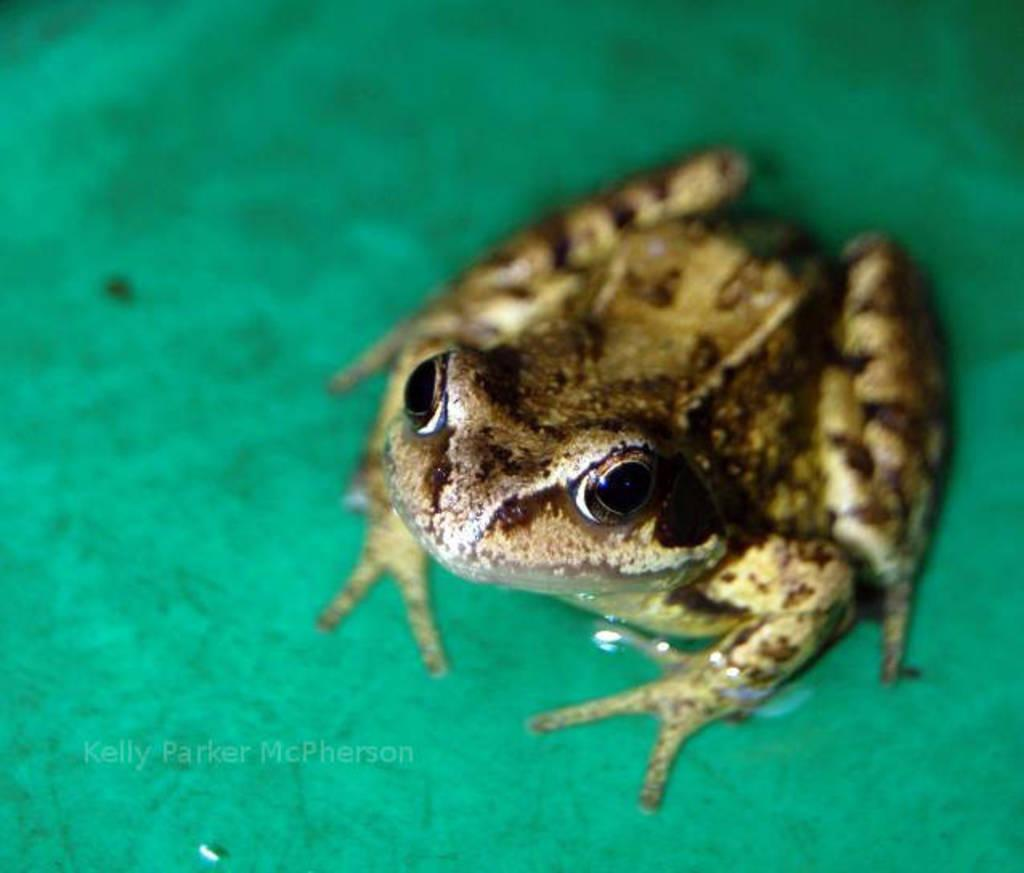What is the main subject of the image? The main subject of the image is a frog. What is the frog sitting on in the image? The frog is on a green surface. What colors can be seen on the frog? The frog has brown and black colors. How does the frog compare to a dime in size in the image? There is no dime present in the image, so it cannot be compared to the frog in size. 